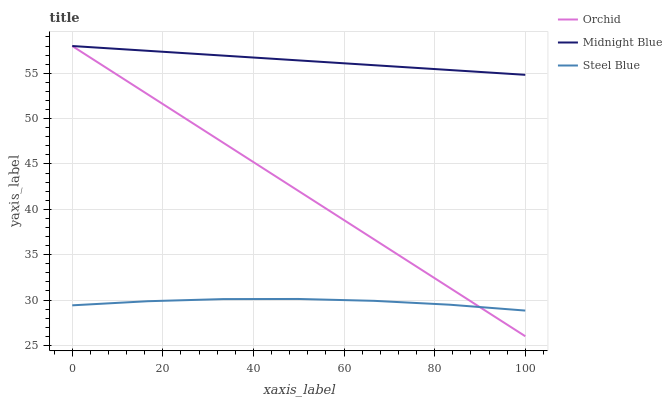Does Steel Blue have the minimum area under the curve?
Answer yes or no. Yes. Does Midnight Blue have the maximum area under the curve?
Answer yes or no. Yes. Does Orchid have the minimum area under the curve?
Answer yes or no. No. Does Orchid have the maximum area under the curve?
Answer yes or no. No. Is Midnight Blue the smoothest?
Answer yes or no. Yes. Is Steel Blue the roughest?
Answer yes or no. Yes. Is Orchid the smoothest?
Answer yes or no. No. Is Orchid the roughest?
Answer yes or no. No. Does Orchid have the lowest value?
Answer yes or no. Yes. Does Midnight Blue have the lowest value?
Answer yes or no. No. Does Orchid have the highest value?
Answer yes or no. Yes. Is Steel Blue less than Midnight Blue?
Answer yes or no. Yes. Is Midnight Blue greater than Steel Blue?
Answer yes or no. Yes. Does Orchid intersect Midnight Blue?
Answer yes or no. Yes. Is Orchid less than Midnight Blue?
Answer yes or no. No. Is Orchid greater than Midnight Blue?
Answer yes or no. No. Does Steel Blue intersect Midnight Blue?
Answer yes or no. No. 